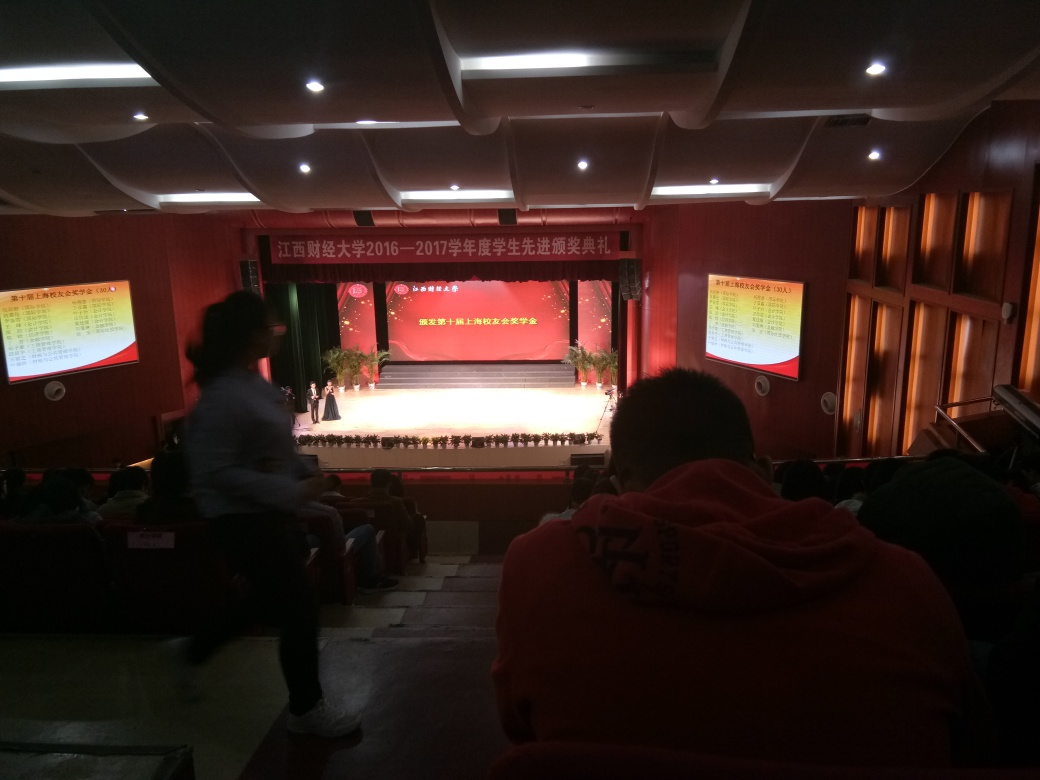What is the lighting condition of the image?
A. Gloomy
B. Harsh
C. Dim
D. Bright The lighting condition of the image seems to be relatively Dim. The overall illumination within the auditorium is modest, and there is no indication of bright lights or a harsh lighting environment. This subdued lighting sets a calmer tone for the audience gathered for the event. 